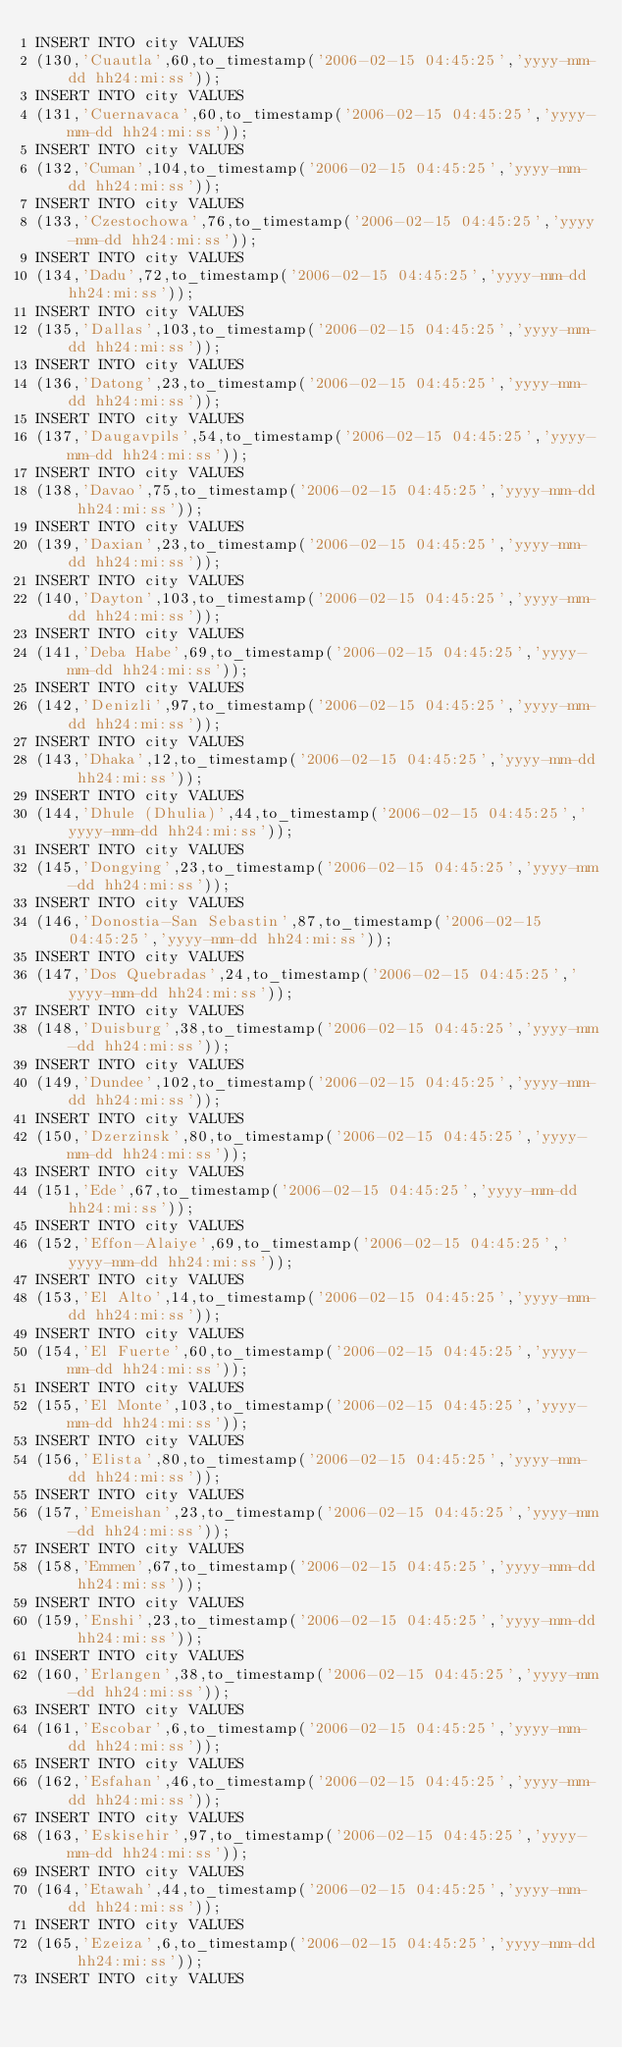Convert code to text. <code><loc_0><loc_0><loc_500><loc_500><_SQL_>INSERT INTO city VALUES
(130,'Cuautla',60,to_timestamp('2006-02-15 04:45:25','yyyy-mm-dd hh24:mi:ss'));
INSERT INTO city VALUES
(131,'Cuernavaca',60,to_timestamp('2006-02-15 04:45:25','yyyy-mm-dd hh24:mi:ss'));
INSERT INTO city VALUES
(132,'Cuman',104,to_timestamp('2006-02-15 04:45:25','yyyy-mm-dd hh24:mi:ss'));
INSERT INTO city VALUES
(133,'Czestochowa',76,to_timestamp('2006-02-15 04:45:25','yyyy-mm-dd hh24:mi:ss'));
INSERT INTO city VALUES
(134,'Dadu',72,to_timestamp('2006-02-15 04:45:25','yyyy-mm-dd hh24:mi:ss'));
INSERT INTO city VALUES
(135,'Dallas',103,to_timestamp('2006-02-15 04:45:25','yyyy-mm-dd hh24:mi:ss'));
INSERT INTO city VALUES
(136,'Datong',23,to_timestamp('2006-02-15 04:45:25','yyyy-mm-dd hh24:mi:ss'));
INSERT INTO city VALUES
(137,'Daugavpils',54,to_timestamp('2006-02-15 04:45:25','yyyy-mm-dd hh24:mi:ss'));
INSERT INTO city VALUES
(138,'Davao',75,to_timestamp('2006-02-15 04:45:25','yyyy-mm-dd hh24:mi:ss'));
INSERT INTO city VALUES
(139,'Daxian',23,to_timestamp('2006-02-15 04:45:25','yyyy-mm-dd hh24:mi:ss'));
INSERT INTO city VALUES
(140,'Dayton',103,to_timestamp('2006-02-15 04:45:25','yyyy-mm-dd hh24:mi:ss'));
INSERT INTO city VALUES
(141,'Deba Habe',69,to_timestamp('2006-02-15 04:45:25','yyyy-mm-dd hh24:mi:ss'));
INSERT INTO city VALUES
(142,'Denizli',97,to_timestamp('2006-02-15 04:45:25','yyyy-mm-dd hh24:mi:ss'));
INSERT INTO city VALUES
(143,'Dhaka',12,to_timestamp('2006-02-15 04:45:25','yyyy-mm-dd hh24:mi:ss'));
INSERT INTO city VALUES
(144,'Dhule (Dhulia)',44,to_timestamp('2006-02-15 04:45:25','yyyy-mm-dd hh24:mi:ss'));
INSERT INTO city VALUES
(145,'Dongying',23,to_timestamp('2006-02-15 04:45:25','yyyy-mm-dd hh24:mi:ss'));
INSERT INTO city VALUES
(146,'Donostia-San Sebastin',87,to_timestamp('2006-02-15 04:45:25','yyyy-mm-dd hh24:mi:ss'));
INSERT INTO city VALUES
(147,'Dos Quebradas',24,to_timestamp('2006-02-15 04:45:25','yyyy-mm-dd hh24:mi:ss'));
INSERT INTO city VALUES
(148,'Duisburg',38,to_timestamp('2006-02-15 04:45:25','yyyy-mm-dd hh24:mi:ss'));
INSERT INTO city VALUES
(149,'Dundee',102,to_timestamp('2006-02-15 04:45:25','yyyy-mm-dd hh24:mi:ss'));
INSERT INTO city VALUES
(150,'Dzerzinsk',80,to_timestamp('2006-02-15 04:45:25','yyyy-mm-dd hh24:mi:ss'));
INSERT INTO city VALUES
(151,'Ede',67,to_timestamp('2006-02-15 04:45:25','yyyy-mm-dd hh24:mi:ss'));
INSERT INTO city VALUES
(152,'Effon-Alaiye',69,to_timestamp('2006-02-15 04:45:25','yyyy-mm-dd hh24:mi:ss'));
INSERT INTO city VALUES
(153,'El Alto',14,to_timestamp('2006-02-15 04:45:25','yyyy-mm-dd hh24:mi:ss'));
INSERT INTO city VALUES
(154,'El Fuerte',60,to_timestamp('2006-02-15 04:45:25','yyyy-mm-dd hh24:mi:ss'));
INSERT INTO city VALUES
(155,'El Monte',103,to_timestamp('2006-02-15 04:45:25','yyyy-mm-dd hh24:mi:ss'));
INSERT INTO city VALUES
(156,'Elista',80,to_timestamp('2006-02-15 04:45:25','yyyy-mm-dd hh24:mi:ss'));
INSERT INTO city VALUES
(157,'Emeishan',23,to_timestamp('2006-02-15 04:45:25','yyyy-mm-dd hh24:mi:ss'));
INSERT INTO city VALUES
(158,'Emmen',67,to_timestamp('2006-02-15 04:45:25','yyyy-mm-dd hh24:mi:ss'));
INSERT INTO city VALUES
(159,'Enshi',23,to_timestamp('2006-02-15 04:45:25','yyyy-mm-dd hh24:mi:ss'));
INSERT INTO city VALUES
(160,'Erlangen',38,to_timestamp('2006-02-15 04:45:25','yyyy-mm-dd hh24:mi:ss'));
INSERT INTO city VALUES
(161,'Escobar',6,to_timestamp('2006-02-15 04:45:25','yyyy-mm-dd hh24:mi:ss'));
INSERT INTO city VALUES
(162,'Esfahan',46,to_timestamp('2006-02-15 04:45:25','yyyy-mm-dd hh24:mi:ss'));
INSERT INTO city VALUES
(163,'Eskisehir',97,to_timestamp('2006-02-15 04:45:25','yyyy-mm-dd hh24:mi:ss'));
INSERT INTO city VALUES
(164,'Etawah',44,to_timestamp('2006-02-15 04:45:25','yyyy-mm-dd hh24:mi:ss'));
INSERT INTO city VALUES
(165,'Ezeiza',6,to_timestamp('2006-02-15 04:45:25','yyyy-mm-dd hh24:mi:ss'));
INSERT INTO city VALUES</code> 